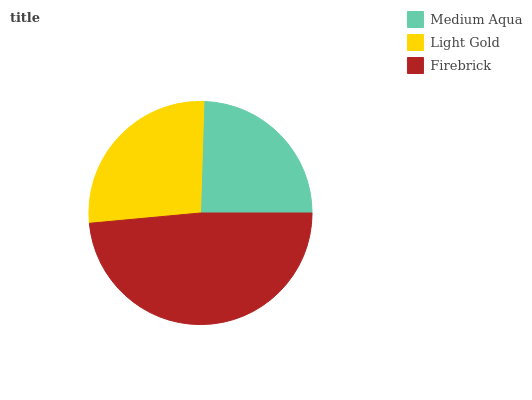Is Medium Aqua the minimum?
Answer yes or no. Yes. Is Firebrick the maximum?
Answer yes or no. Yes. Is Light Gold the minimum?
Answer yes or no. No. Is Light Gold the maximum?
Answer yes or no. No. Is Light Gold greater than Medium Aqua?
Answer yes or no. Yes. Is Medium Aqua less than Light Gold?
Answer yes or no. Yes. Is Medium Aqua greater than Light Gold?
Answer yes or no. No. Is Light Gold less than Medium Aqua?
Answer yes or no. No. Is Light Gold the high median?
Answer yes or no. Yes. Is Light Gold the low median?
Answer yes or no. Yes. Is Firebrick the high median?
Answer yes or no. No. Is Firebrick the low median?
Answer yes or no. No. 